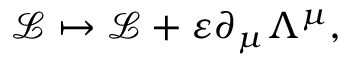Convert formula to latex. <formula><loc_0><loc_0><loc_500><loc_500>{ \mathcal { L } } \mapsto { \mathcal { L } } + \varepsilon \partial _ { \mu } \Lambda ^ { \mu } ,</formula> 